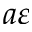Convert formula to latex. <formula><loc_0><loc_0><loc_500><loc_500>a \varepsilon</formula> 